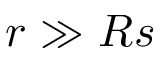Convert formula to latex. <formula><loc_0><loc_0><loc_500><loc_500>r \gg R s</formula> 